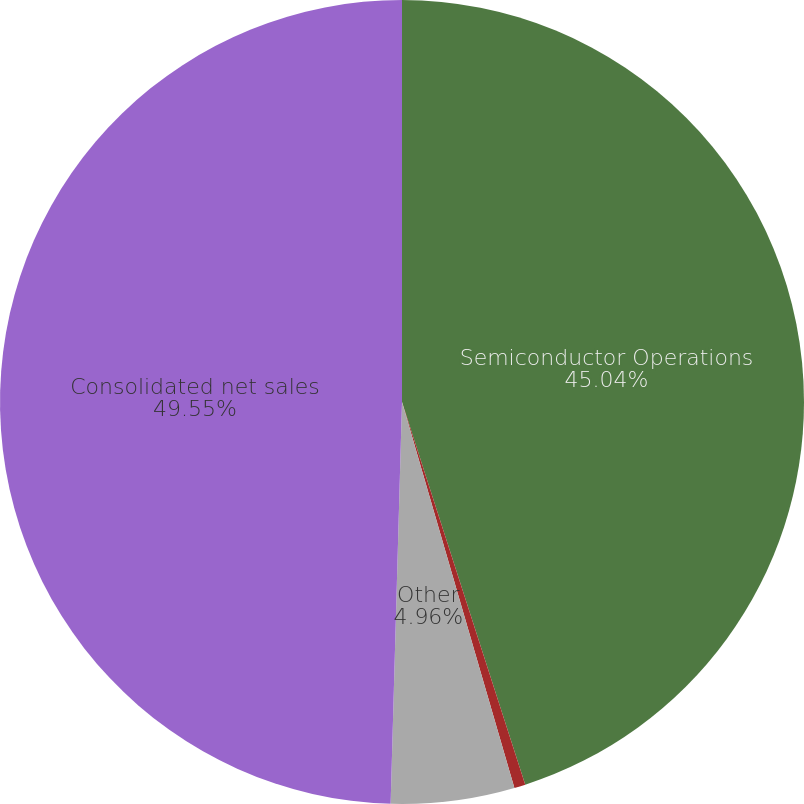<chart> <loc_0><loc_0><loc_500><loc_500><pie_chart><fcel>Semiconductor Operations<fcel>Web-hosting Operations<fcel>Other<fcel>Consolidated net sales<nl><fcel>45.04%<fcel>0.45%<fcel>4.96%<fcel>49.55%<nl></chart> 